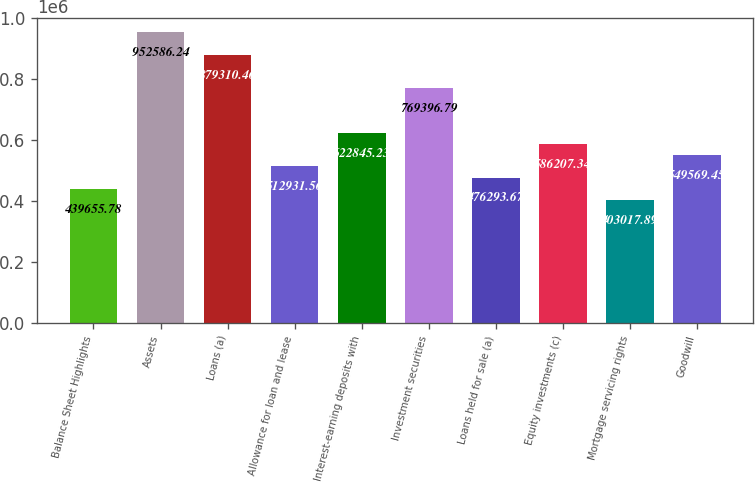Convert chart. <chart><loc_0><loc_0><loc_500><loc_500><bar_chart><fcel>Balance Sheet Highlights<fcel>Assets<fcel>Loans (a)<fcel>Allowance for loan and lease<fcel>Interest-earning deposits with<fcel>Investment securities<fcel>Loans held for sale (a)<fcel>Equity investments (c)<fcel>Mortgage servicing rights<fcel>Goodwill<nl><fcel>439656<fcel>952586<fcel>879310<fcel>512932<fcel>622845<fcel>769397<fcel>476294<fcel>586207<fcel>403018<fcel>549569<nl></chart> 